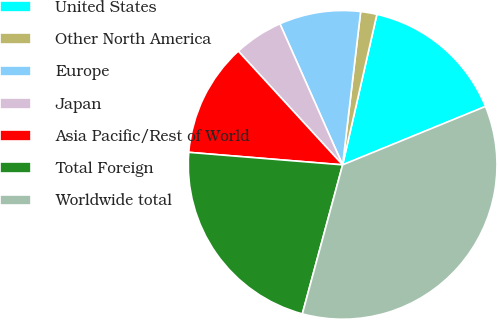<chart> <loc_0><loc_0><loc_500><loc_500><pie_chart><fcel>United States<fcel>Other North America<fcel>Europe<fcel>Japan<fcel>Asia Pacific/Rest of World<fcel>Total Foreign<fcel>Worldwide total<nl><fcel>15.26%<fcel>1.7%<fcel>8.52%<fcel>5.16%<fcel>11.89%<fcel>22.09%<fcel>35.38%<nl></chart> 